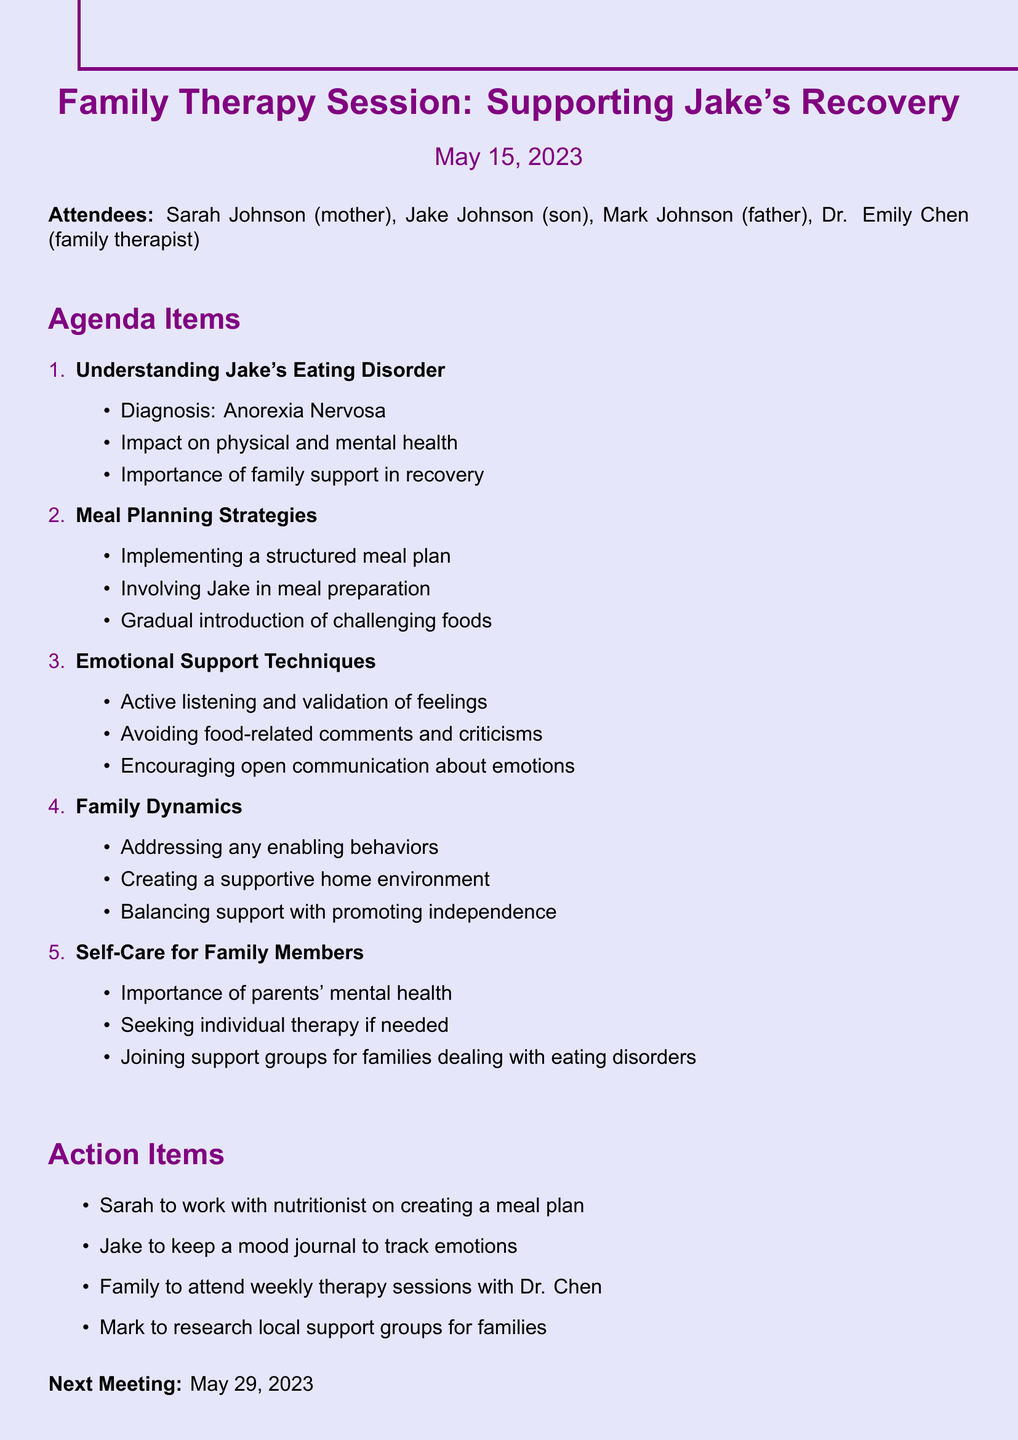What is the date of the meeting? The date of the meeting is specified at the beginning of the document.
Answer: May 15, 2023 Who is the family therapist present? The document lists attendees, including the family therapist.
Answer: Dr. Emily Chen What is Jake's diagnosis? The diagnosis is mentioned under the agenda topic regarding Jake's eating disorder.
Answer: Anorexia Nervosa What is one action item for Sarah? The action items section specifies responsibilities for each family member.
Answer: Work with nutritionist on creating a meal plan What is the focus of the emotional support techniques discussed? The document lists important points under emotional support techniques.
Answer: Active listening and validation of feelings How often will the family attend therapy sessions? The document states the frequency of therapy sessions in the action items.
Answer: Weekly What key aspect is mentioned under family dynamics? Family dynamics section discusses different considerations for providing support.
Answer: Addressing any enabling behaviors What is a self-care suggestion for family members? Self-care for family members lists important actions for parents' mental health.
Answer: Seeking individual therapy if needed 